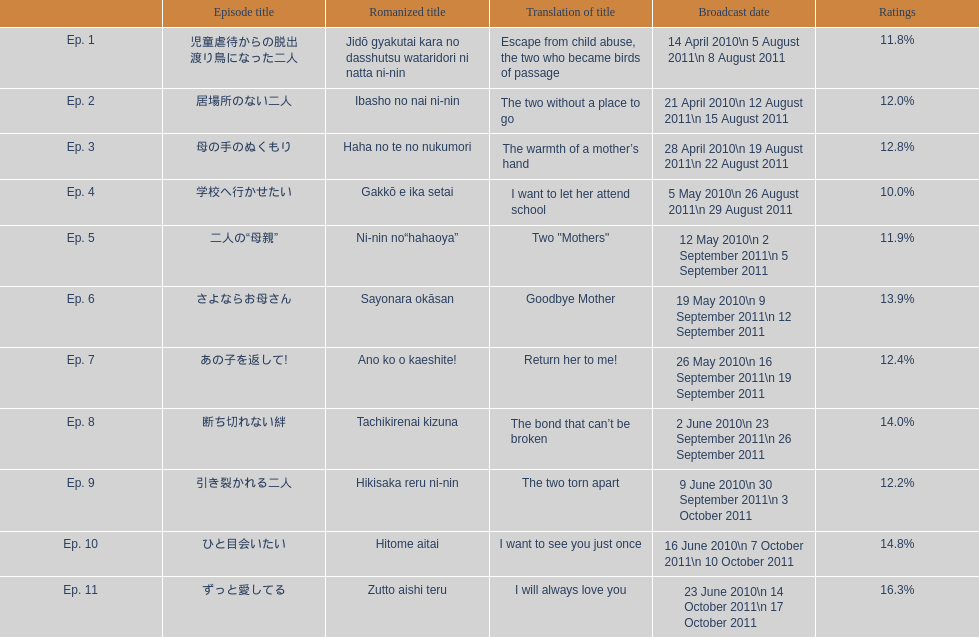What was the most acclaimed episode of this show? ずっと愛してる. 